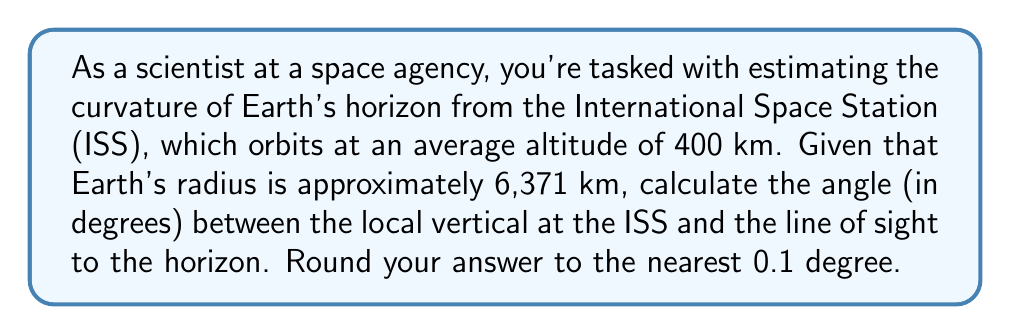What is the answer to this math problem? To solve this problem, we'll use the following approach:

1. Visualize the geometry of the situation:
[asy]
import geometry;

real R = 6371;
real h = 400;
real scale = 100/R;

pair O = (0,0);
pair C = (0,R*scale);
pair S = (0,(R+h)*scale);

draw(circle(O, R*scale), rgb(0,0.5,0));
draw(O--S, dashed);
draw(C--S);
draw(O--C--((R+h)*scale,0)--cycle);

label("O (Earth's center)", O, SW);
label("C (Earth's surface)", C, W);
label("S (ISS)", S, N);
label("R", (0,R*scale/2), W);
label("h", (0,R*scale + h*scale/2), E);
label("$\theta$", (5,(R+h)*scale-5), NE);

dot(O);
dot(C);
dot(S);
[/asy]

2. In this diagram, O is Earth's center, C is a point on Earth's surface, and S is the position of the ISS.

3. The angle we're looking for is $\theta$, which is formed between the local vertical (line OS) and the line of sight to the horizon (line SC).

4. We can find this angle using the right triangle OSC. We know:
   - OC = R (Earth's radius) = 6,371 km
   - OS = R + h = 6,371 km + 400 km = 6,771 km

5. In the right triangle OSC, we can use the cosine function:

   $$\cos(\theta) = \frac{OC}{OS} = \frac{R}{R+h}$$

6. Substituting the values:

   $$\cos(\theta) = \frac{6371}{6771} \approx 0.9409$$

7. To find $\theta$, we take the inverse cosine (arccos):

   $$\theta = \arccos(0.9409) \approx 0.3431 \text{ radians}$$

8. Convert radians to degrees:

   $$\theta = 0.3431 \times \frac{180}{\pi} \approx 19.65°$$

9. Rounding to the nearest 0.1 degree gives us 19.7°.
Answer: 19.7° 